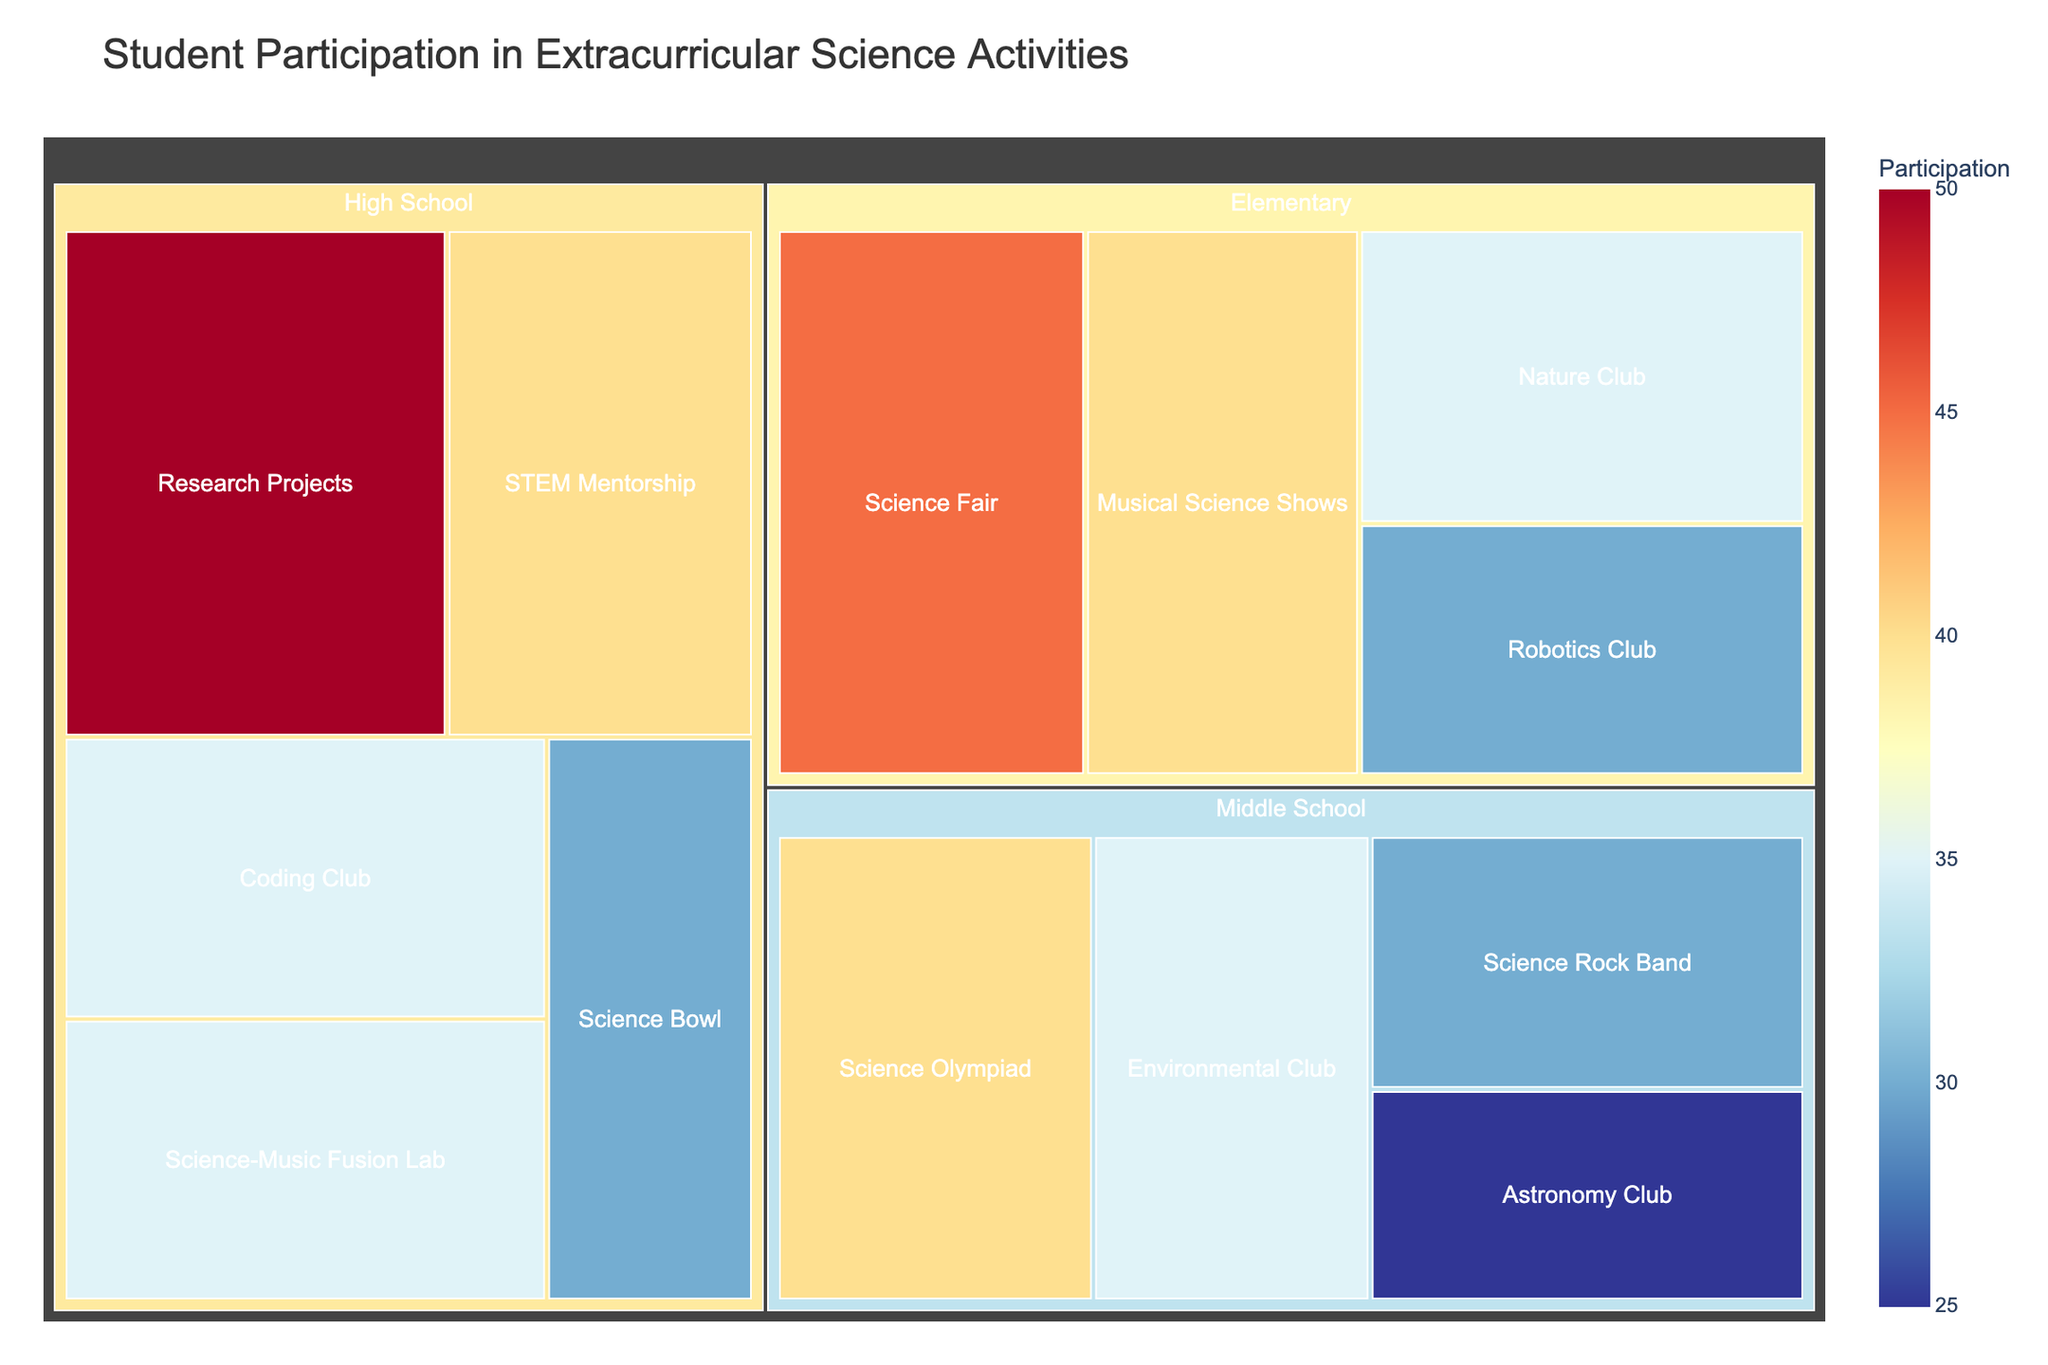What's the title of the plot? The title is displayed at the top center of the plot.
Answer: Student Participation in Extracurricular Science Activities Which activity in the Elementary grade level has the highest participation count? Looking at the Elementary section of the treemap, identify the activity with the largest area or darkest color.
Answer: Science Fair How many students participated in the Science Olympiad? Find the Middle School section and look for the "Science Olympiad" block. The participation count is displayed inside or by hovering over the block.
Answer: 40 Which grade level has the highest overall participation count in extracurricular science activities? Compare the combined participation counts of each grade level. The grade level with the largest aggregated area represents the highest overall participation.
Answer: High School What is the difference in participation counts between the High School "Research Projects" and "Science-Music Fusion Lab"? Locate both blocks, retrieve their participation counts, and calculate the difference: 50 (Research Projects) - 35 (Science-Music Fusion Lab).
Answer: 15 Which activity type across all grade levels has the smallest participation count? Identify the smallest block or the lightest shade, indicating the lowest participation count.
Answer: Astronomy Club How does the participation for Elementary Robotics Club compare to Middle School Environmental Club? Locate the corresponding blocks and compare their sizes and colors. The Elementary Robotics Club has 30, and the Middle School Environmental Club has 35.
Answer: Elementary Robotics Club has 5 fewer participants than Middle School Environmental Club What is the total participation count for all activities in Middle School? Sum all the participation counts of Middle School activities: 40 (Science Olympiad) + 25 (Astronomy Club) + 35 (Environmental Club) + 30 (Science Rock Band).
Answer: 130 Which activity type is unique to each grade level? Identify activities that appear in only one grade level by checking the labels in each section.
Answer: Elementary: Musical Science Shows, Middle School: Science Rock Band, High School: Science-Music Fusion Lab How does the popularity of music-integrated science activities compare across different grade levels? Compare the participation counts of "Musical Science Shows" for Elementary (40), "Science Rock Band" for Middle School (30), and "Science-Music Fusion Lab" for High School (35).
Answer: Elementary has the highest with 40, followed by High School with 35, then Middle School with 30 